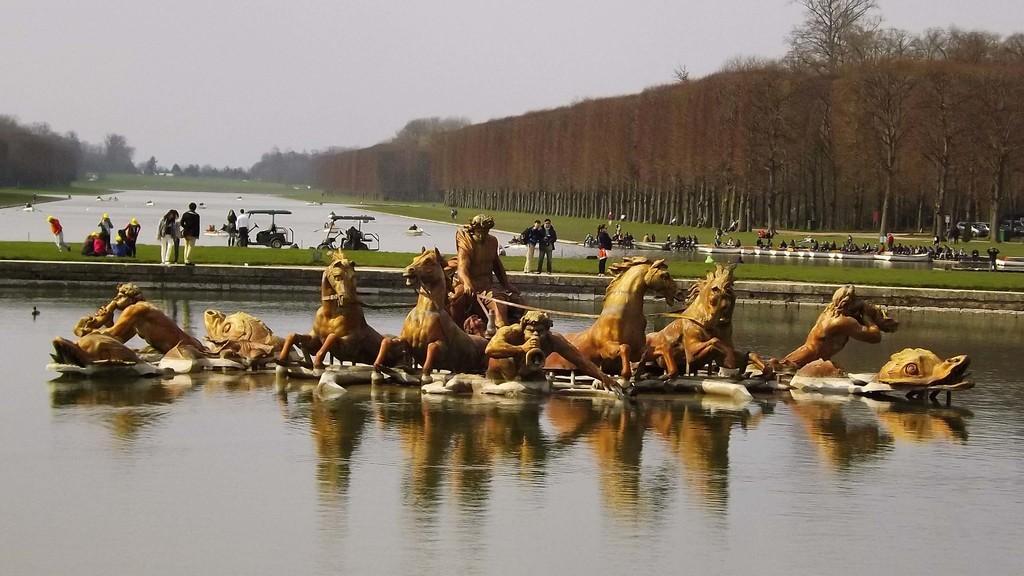Could you give a brief overview of what you see in this image? The picture is taken outside a city. In the foreground of the picture there is water, in the water there is a sculpture of horses and men. In the center of the picture there are people standing, on the grass. In the background there are trees, water, birds and few people. Sky is little bit cloudy. 